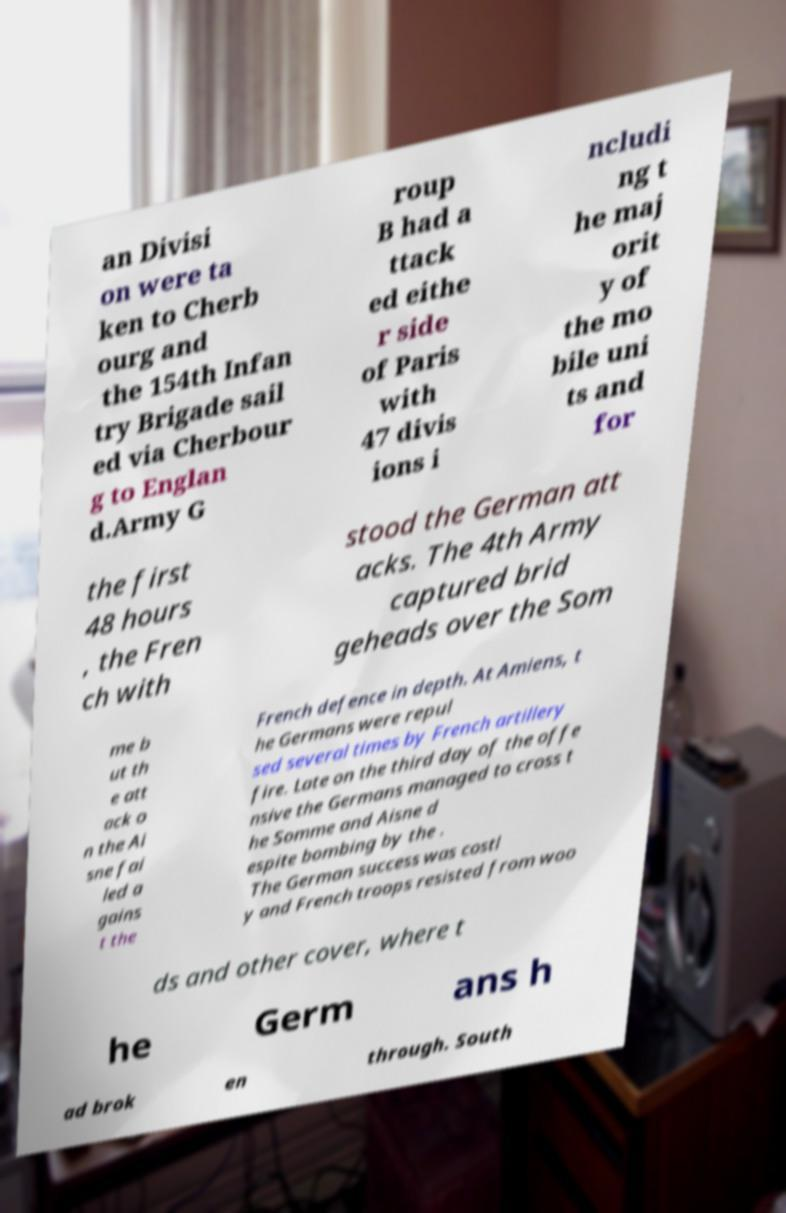I need the written content from this picture converted into text. Can you do that? an Divisi on were ta ken to Cherb ourg and the 154th Infan try Brigade sail ed via Cherbour g to Englan d.Army G roup B had a ttack ed eithe r side of Paris with 47 divis ions i ncludi ng t he maj orit y of the mo bile uni ts and for the first 48 hours , the Fren ch with stood the German att acks. The 4th Army captured brid geheads over the Som me b ut th e att ack o n the Ai sne fai led a gains t the French defence in depth. At Amiens, t he Germans were repul sed several times by French artillery fire. Late on the third day of the offe nsive the Germans managed to cross t he Somme and Aisne d espite bombing by the . The German success was costl y and French troops resisted from woo ds and other cover, where t he Germ ans h ad brok en through. South 